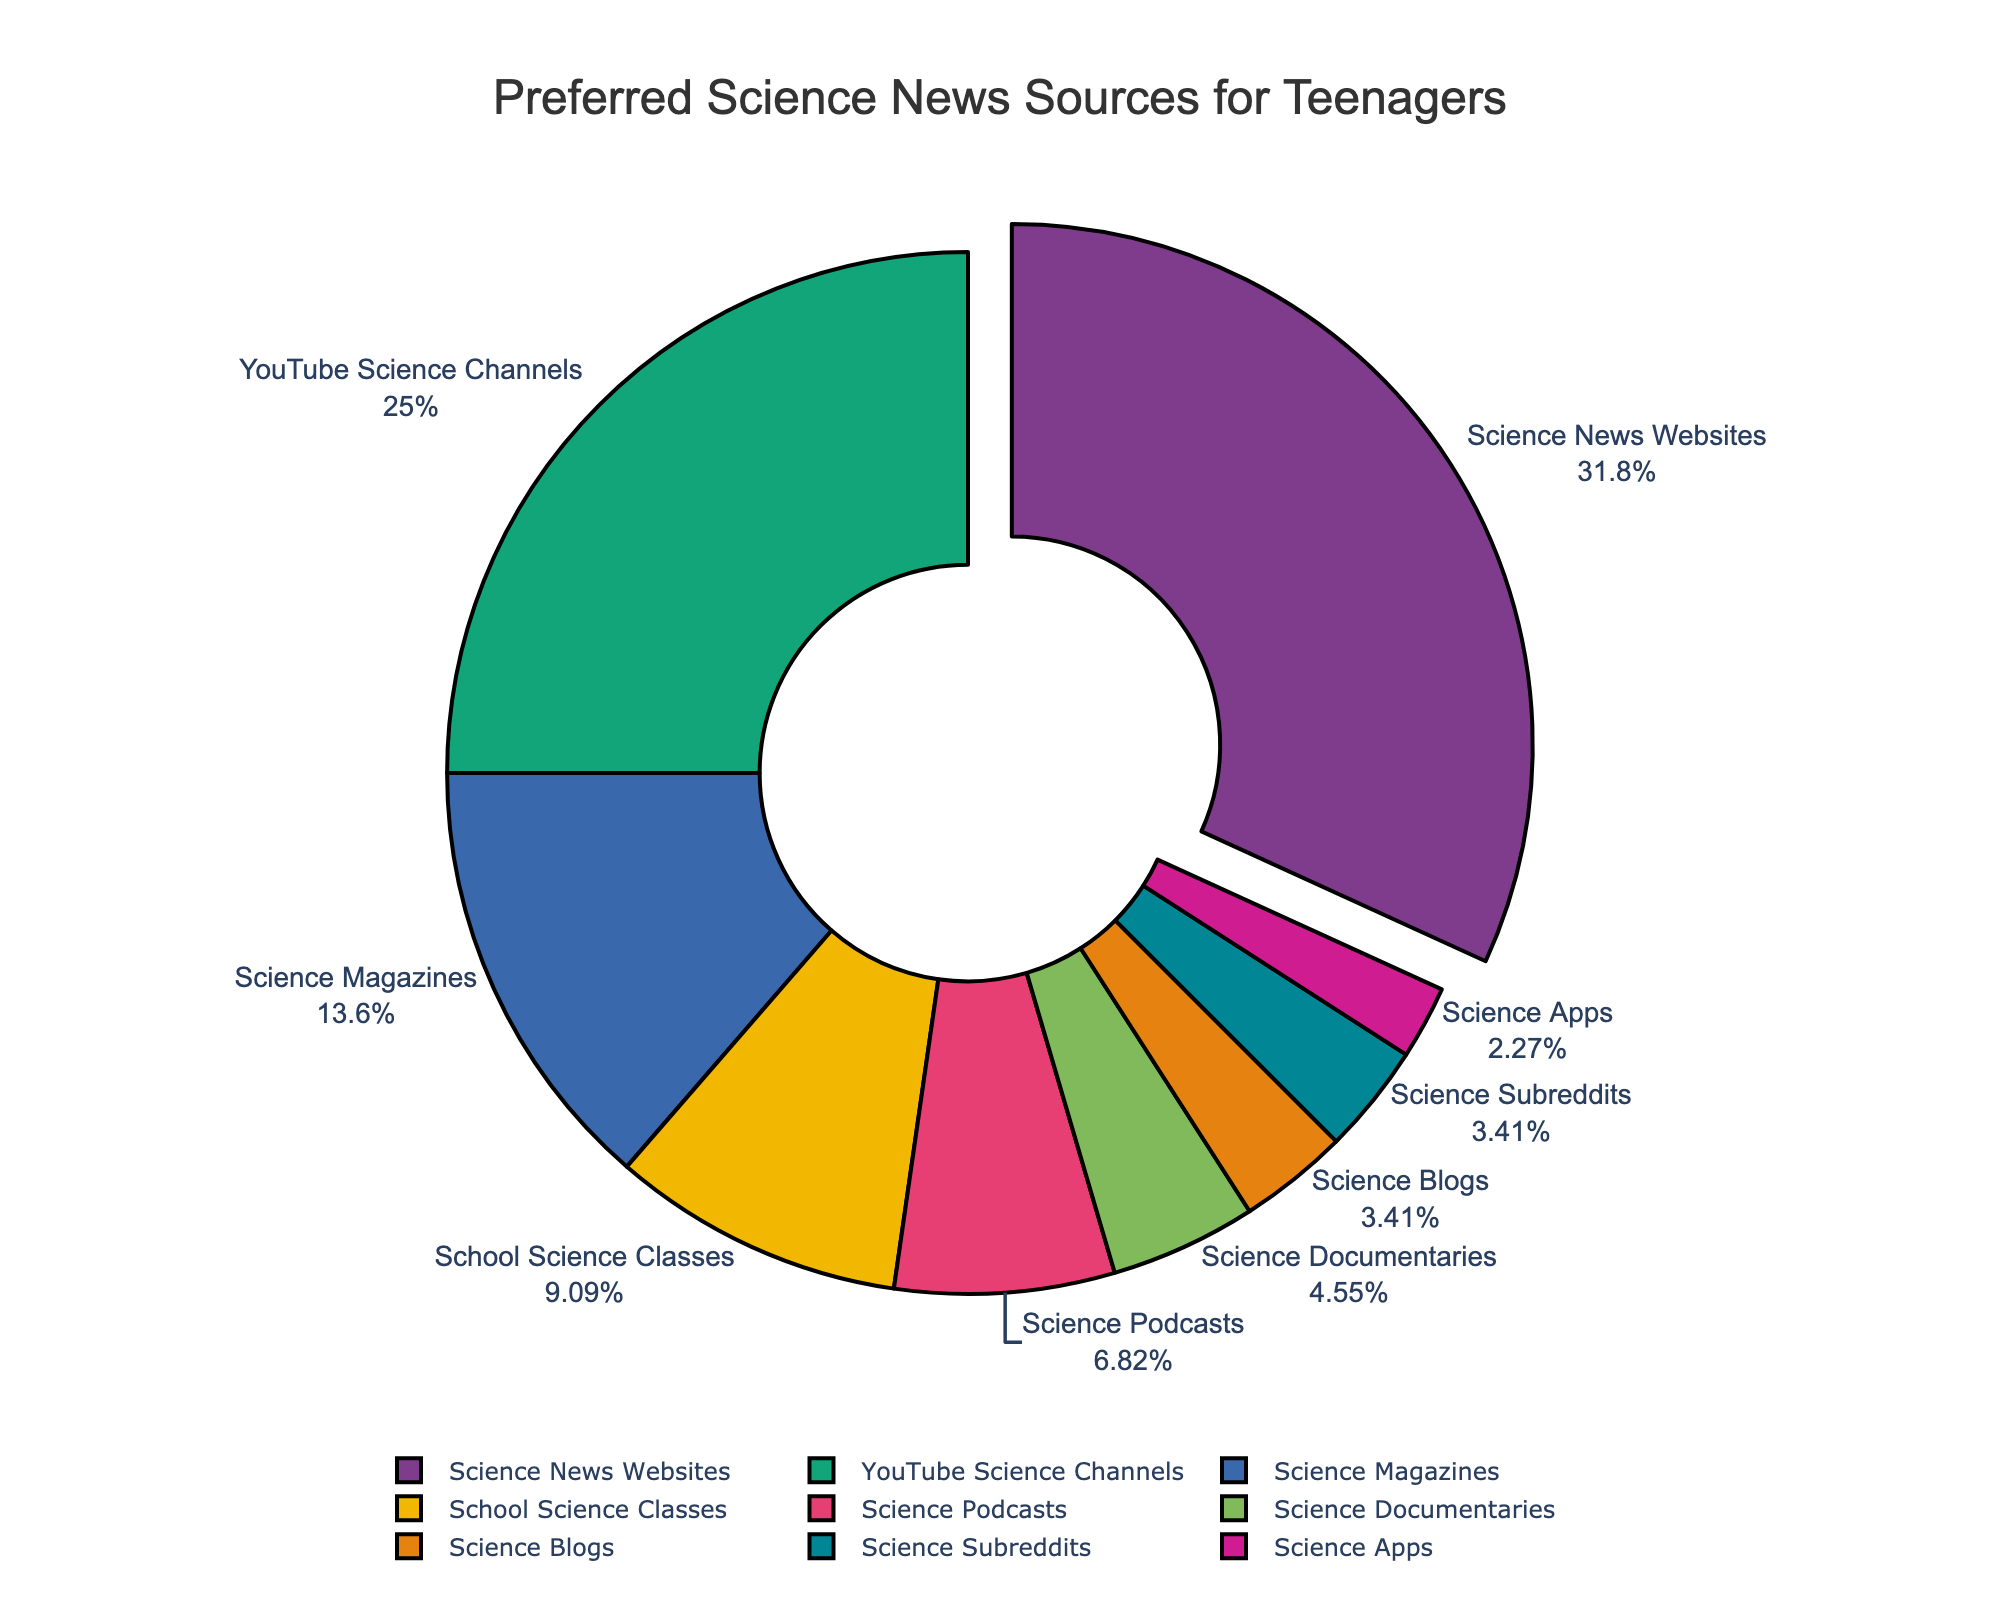What is the most preferred source of science news among teenagers? By looking at the pie chart, we can see that 'Science News Websites' has the largest slice pulled away from the pie chart, indicating it has the highest percentage.
Answer: Science News Websites Which information source has a higher percentage: YouTube Science Channels or Science Documentaries? Comparing the two slices on the pie chart, 'YouTube Science Channels' has a larger slice than 'Science Documentaries'.
Answer: YouTube Science Channels What is the total percentage of teenagers who prefer Science Magazines, Science Podcasts, and Science Documentaries combined? We need to sum the percentages of these sources from the pie chart: 12% (Science Magazines) + 6% (Science Podcasts) + 4% (Science Documentaries) = 22%.
Answer: 22% How much more popular are Science News Websites compared to School Science Classes in terms of percentage? We subtract the percentage of School Science Classes from the percentage of Science News Websites: 28% - 8% = 20%.
Answer: 20% Which information source is the least preferred by teenagers? According to the pie chart, 'Science Apps' has the smallest slice, indicating the lowest percentage.
Answer: Science Apps How do the combined percentages of Science Blogs and Science Subreddits compare to YouTube Science Channels? We sum the percentages of Science Blogs and Science Subreddits: 3% + 3% = 6%. Next, we compare it to YouTube Science Channels (22%). 6% is less than 22%.
Answer: Less What percentage of teenagers prefer sources other than Science News Websites, YouTube Science Channels, or Science Magazines? We sum the percentages of all other sources (100% - (28% + 22% + 12%)): 100% - 62% = 38%.
Answer: 38% Which preferred information source has a percentage close to that of Science Documentaries? According to the pie chart, 'Science Blogs' and 'Science Subreddits', both at 3%, are closest to the 4% of 'Science Documentaries'.
Answer: Science Blogs and Science Subreddits 